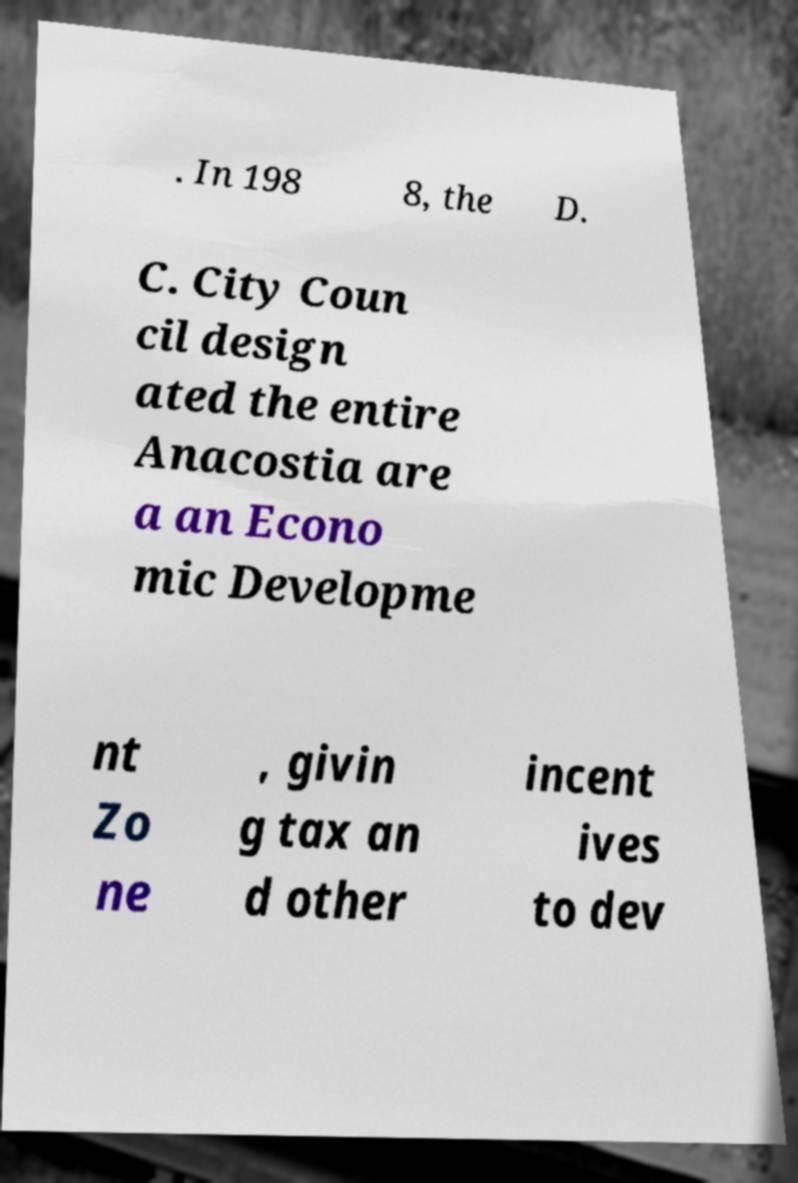Please read and relay the text visible in this image. What does it say? . In 198 8, the D. C. City Coun cil design ated the entire Anacostia are a an Econo mic Developme nt Zo ne , givin g tax an d other incent ives to dev 